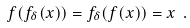Convert formula to latex. <formula><loc_0><loc_0><loc_500><loc_500>f ( f _ { \delta } ( x ) ) = f _ { \delta } ( f ( x ) ) = x \ .</formula> 